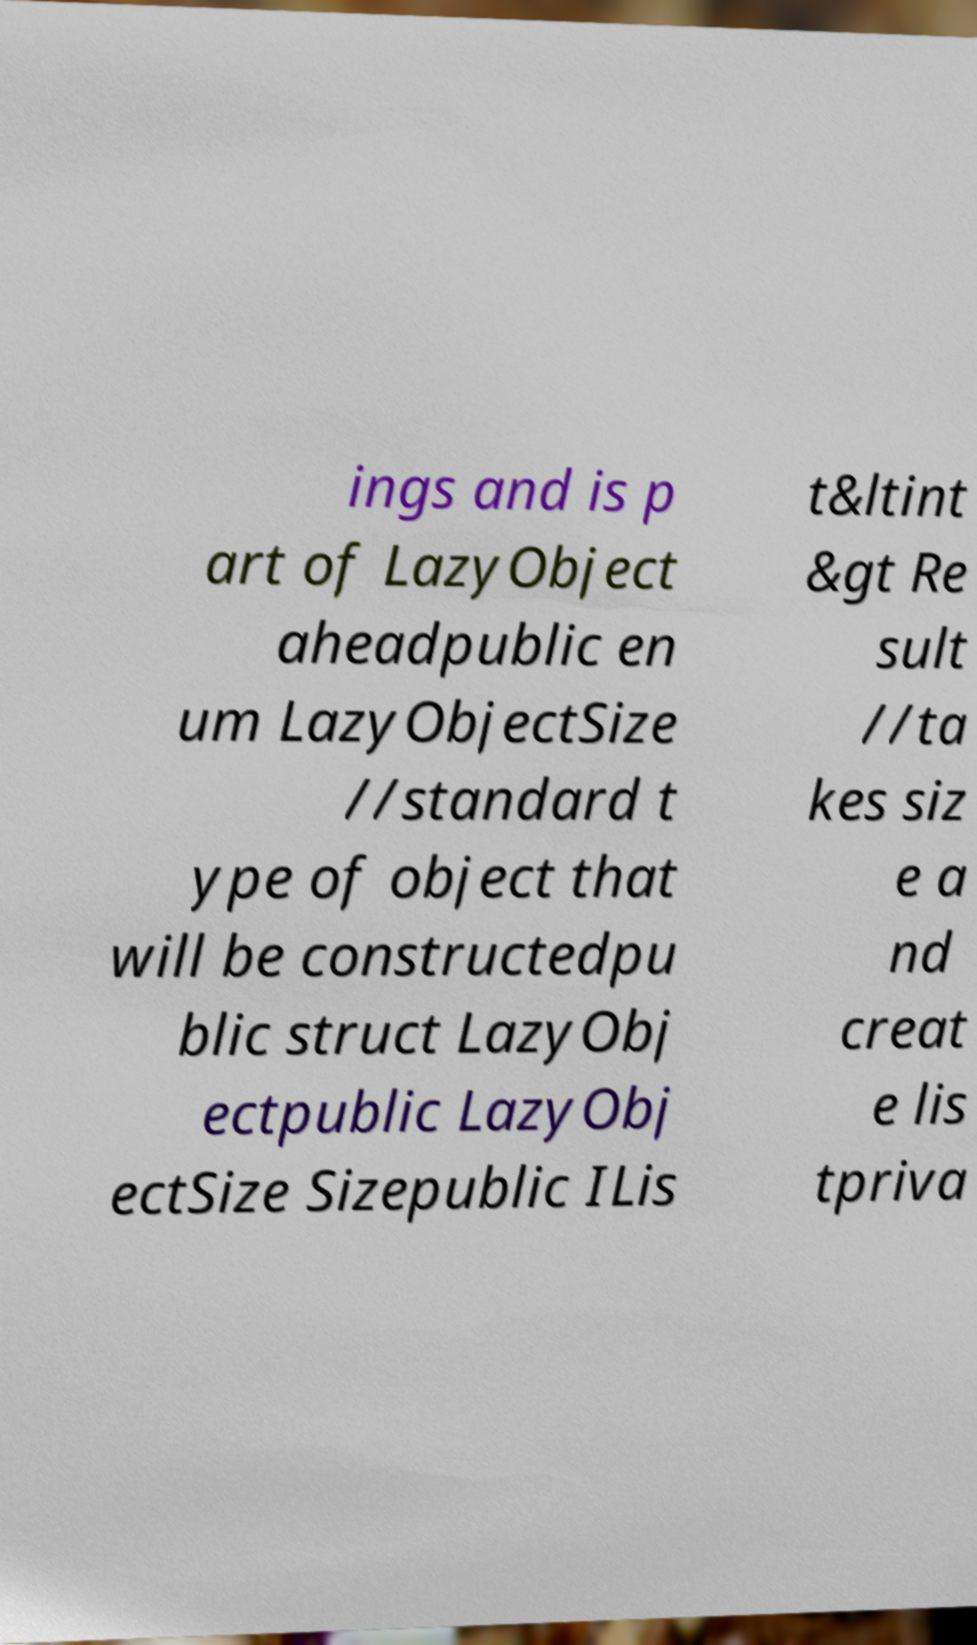Can you accurately transcribe the text from the provided image for me? ings and is p art of LazyObject aheadpublic en um LazyObjectSize //standard t ype of object that will be constructedpu blic struct LazyObj ectpublic LazyObj ectSize Sizepublic ILis t&ltint &gt Re sult //ta kes siz e a nd creat e lis tpriva 